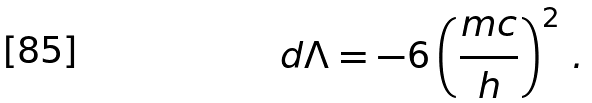<formula> <loc_0><loc_0><loc_500><loc_500>d \Lambda = - 6 \left ( \frac { m c } { h } \right ) ^ { 2 } \, .</formula> 